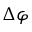Convert formula to latex. <formula><loc_0><loc_0><loc_500><loc_500>\Delta \varphi</formula> 